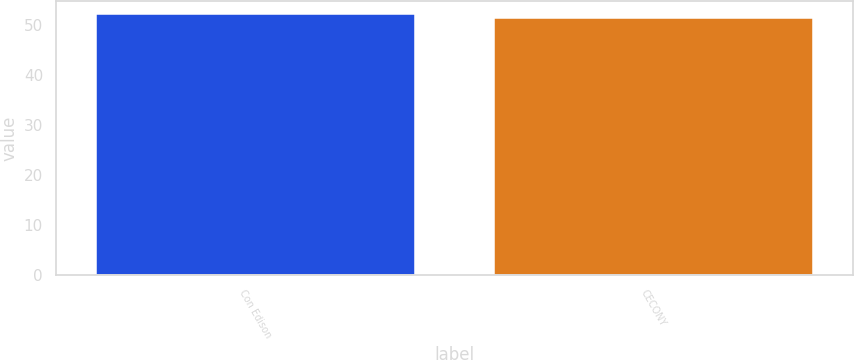Convert chart to OTSL. <chart><loc_0><loc_0><loc_500><loc_500><bar_chart><fcel>Con Edison<fcel>CECONY<nl><fcel>52.1<fcel>51.4<nl></chart> 